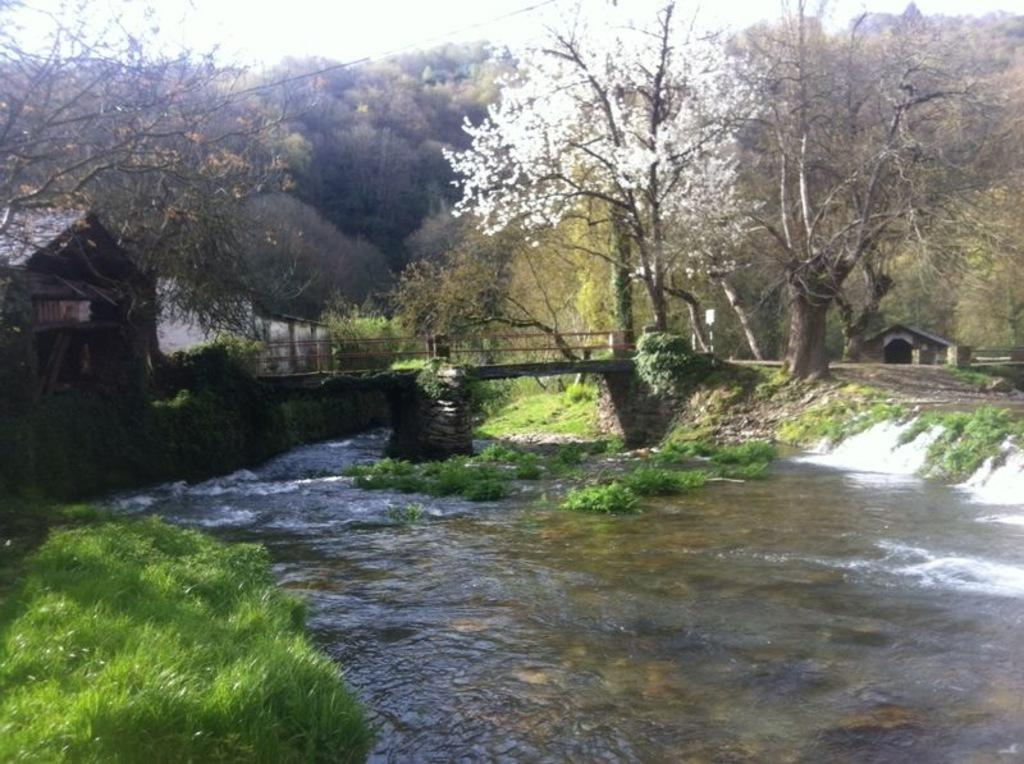What type of vegetation can be seen in the image? There are trees in the image. What man-made structure is present in the image? There is a bridge in the image. What type of ground cover is visible in the image? There is grass in the image. What type of building is present in the image? There is a house in the image. What natural element is present in the image? There is water in the image. Can you describe the background of the image? There is a house in the background of the image, and the sky is visible in the background of the image. What type of account is being discussed in the image? There is no account being discussed in the image; it features trees, a bridge, grass, a house, water, and a background with a house and sky. 